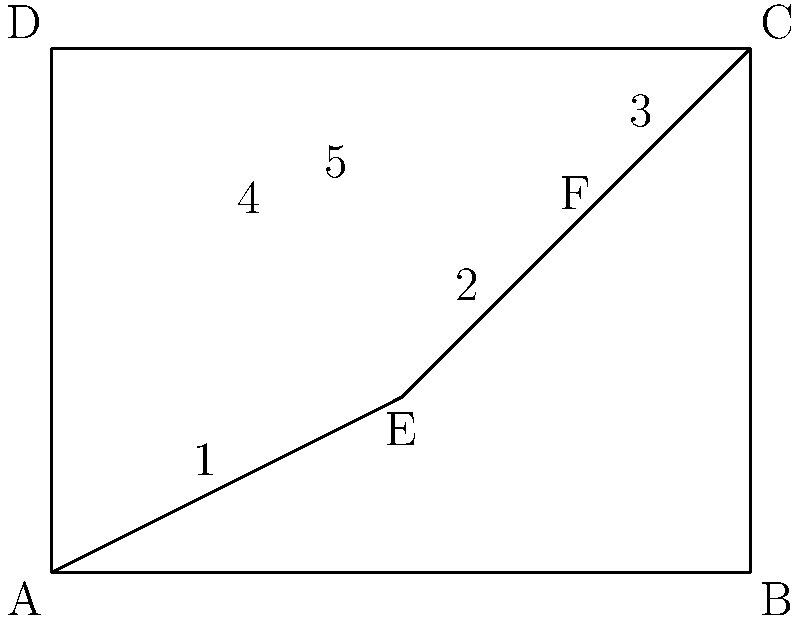In the diagram, quadrilateral $ABCD$ is divided into four smaller quadrilaterals. Prove that quadrilateral $1$ is congruent to quadrilateral $5$ without using any trigonometric functions or angle measurements. How many congruence criteria do you need to use to complete the proof? Let's approach this step-by-step:

1) First, we need to identify the quadrilaterals in question. Quadrilateral 1 is $AEOA$ (where $O$ is the intersection of $AE$ and $DC$), and quadrilateral 5 is $FCOF$.

2) To prove congruence, we need to show that all corresponding sides and angles are equal. We can do this using the Side-Side-Side (SSS) congruence criterion.

3) Let's start with the sides:
   a) $AE = FC$ (given as diagonals of rectangle $ABCD$)
   b) $EO = OF$ (as $E$ and $F$ are midpoints of $AD$ and $BC$ respectively)
   c) $AO = CO$ (as $O$ is the midpoint of $DC$)

4) With SSS, we have now proved that triangle $AEO$ is congruent to triangle $CFO$.

5) This means that all corresponding angles in these triangles are equal:
   $\angle EAO = \angle FCO$
   $\angle AEO = \angle CFO$
   $\angle AOE = \angle COF$

6) The fourth angle in each quadrilateral is a right angle (as they are in the corners of rectangle $ABCD$).

7) Thus, all four sides and all four angles of quadrilateral $AEOA$ are equal to the corresponding sides and angles of quadrilateral $FCOF$.

Therefore, quadrilateral 1 (AEOA) is congruent to quadrilateral 5 (FCOF). We only needed to use one congruence criterion (SSS) to complete this proof.
Answer: 1 (SSS) 